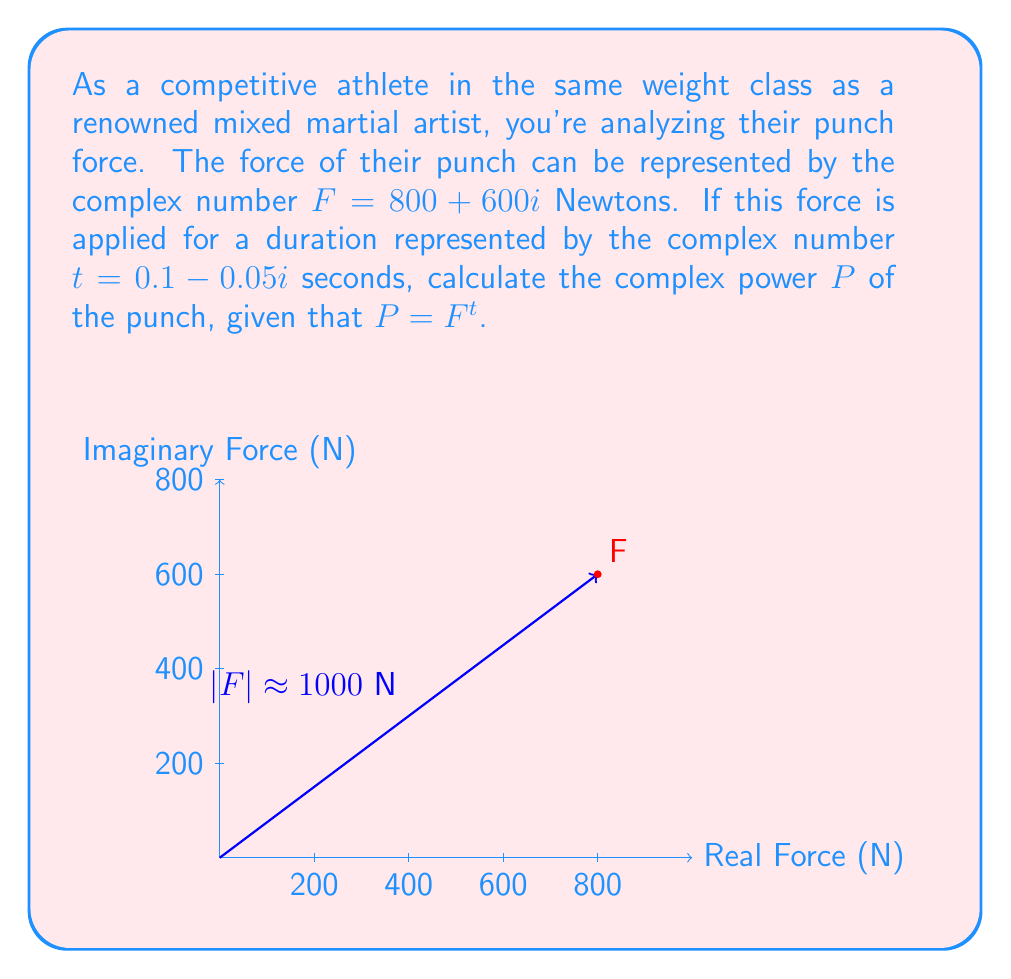Can you answer this question? To solve this problem, we need to use the complex power formula:

$$P = F^t = e^{t \ln(F)}$$

Step 1: Calculate $\ln(F)$
$$F = 800 + 600i = re^{i\theta}$$
$$r = \sqrt{800^2 + 600^2} = 1000$$
$$\theta = \arctan(\frac{600}{800}) \approx 0.6435 \text{ radians}$$
$$\ln(F) = \ln(1000) + 0.6435i \approx 6.9078 + 0.6435i$$

Step 2: Multiply $t$ and $\ln(F)$
$$t \ln(F) = (0.1 - 0.05i)(6.9078 + 0.6435i)$$
$$ = 0.69078 + 0.06435i - 0.34539i - 0.032175$$
$$ = 0.658605 - 0.28104i$$

Step 3: Calculate $e^{t \ln(F)}$
$$P = e^{0.658605 - 0.28104i}$$
$$ = e^{0.658605}(\cos(-0.28104) + i\sin(-0.28104))$$
$$ \approx 1.9321(0.9610 - 0.2765i)$$
$$ \approx 1.8567 - 0.5342i$$

Therefore, the complex power $P$ of the punch is approximately $1.8567 - 0.5342i$ Watts.
Answer: $P \approx 1.8567 - 0.5342i$ W 